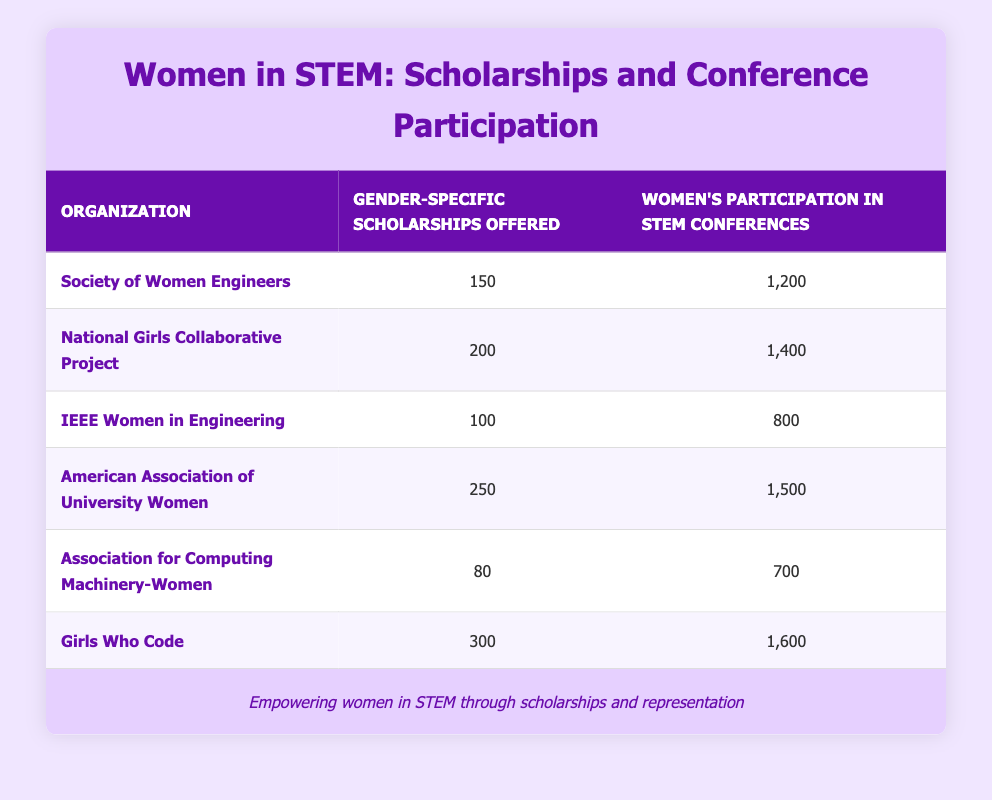What is the highest number of gender-specific scholarships offered by an organization in the table? The table shows the number of scholarships for each organization. The American Association of University Women offers 250 scholarships, while Girls Who Code offers the highest with 300 scholarships. Therefore, the highest number of gender-specific scholarships is 300.
Answer: 300 What is the total women participation in STEM conferences across all organizations? To find the total participation, we add up the participation numbers: 1200 + 1400 + 800 + 1500 + 700 + 1600 = 6200. Therefore, the total women participation is 6200.
Answer: 6200 Is it true that the IEEE Women in Engineering has the lowest women participation in STEM conferences? Looking at the participation values, IEEE Women in Engineering has 800 participants, which is lower than the others. Thus, it is true that they have the lowest participation.
Answer: Yes How many more scholarships did Girls Who Code offer compared to the Association for Computing Machinery-Women? Girls Who Code offers 300 scholarships while Association for Computing Machinery-Women offers 80. The difference is calculated as 300 - 80 = 220. Therefore, Girls Who Code offered 220 more scholarships.
Answer: 220 What is the average number of women's participation in STEM conferences across the organizations listed? To find the average, we add the participation values: 1200 + 1400 + 800 + 1500 + 700 + 1600 = 6200, and divide by the number of organizations (6). 6200 / 6 = approximately 1033.33. Thus, the average participation is around 1033.33.
Answer: 1033.33 How many organizations offered more than 200 gender-specific scholarships? From the data, the organizations offering more than 200 scholarships are National Girls Collaborative Project (200) and Girls Who Code (300), totaling 2 organizations that meet this criterion.
Answer: 2 Which organization had the highest women's participation among those that offered fewer than 150 gender-specific scholarships? Among those offering fewer than 150 scholarships, the organizations are IEEE Women in Engineering (800) and Association for Computing Machinery-Women (700). The highest participation is from IEEE Women in Engineering with 800 participants.
Answer: IEEE Women in Engineering What is the difference in women's participation in STEM conferences between the organization with the most scholarships and the one with the least? Girls Who Code offers 300 scholarships (highest) and IEEE Women in Engineering offers 100 scholarships (least). The women's participation numbers are 1600 and 800, respectively. The difference is calculated as 1600 - 800 = 800.
Answer: 800 How many organizations had a participation number greater than 1000? The organizations with participation numbers greater than 1000 are Society of Women Engineers (1200), National Girls Collaborative Project (1400), American Association of University Women (1500), and Girls Who Code (1600). There are a total of 4 organizations.
Answer: 4 